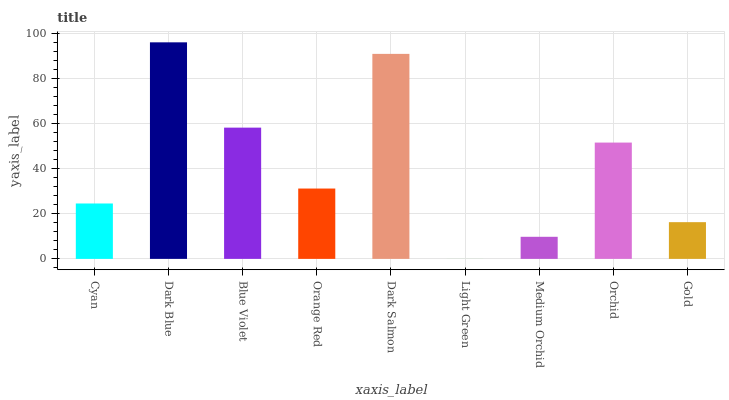Is Light Green the minimum?
Answer yes or no. Yes. Is Dark Blue the maximum?
Answer yes or no. Yes. Is Blue Violet the minimum?
Answer yes or no. No. Is Blue Violet the maximum?
Answer yes or no. No. Is Dark Blue greater than Blue Violet?
Answer yes or no. Yes. Is Blue Violet less than Dark Blue?
Answer yes or no. Yes. Is Blue Violet greater than Dark Blue?
Answer yes or no. No. Is Dark Blue less than Blue Violet?
Answer yes or no. No. Is Orange Red the high median?
Answer yes or no. Yes. Is Orange Red the low median?
Answer yes or no. Yes. Is Gold the high median?
Answer yes or no. No. Is Gold the low median?
Answer yes or no. No. 